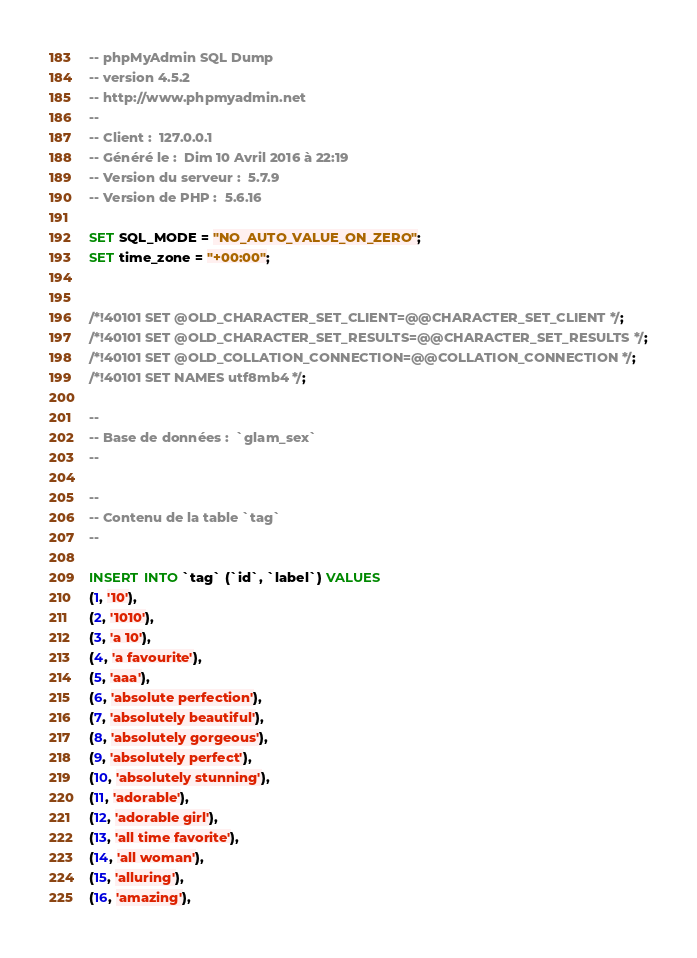Convert code to text. <code><loc_0><loc_0><loc_500><loc_500><_SQL_>-- phpMyAdmin SQL Dump
-- version 4.5.2
-- http://www.phpmyadmin.net
--
-- Client :  127.0.0.1
-- Généré le :  Dim 10 Avril 2016 à 22:19
-- Version du serveur :  5.7.9
-- Version de PHP :  5.6.16

SET SQL_MODE = "NO_AUTO_VALUE_ON_ZERO";
SET time_zone = "+00:00";


/*!40101 SET @OLD_CHARACTER_SET_CLIENT=@@CHARACTER_SET_CLIENT */;
/*!40101 SET @OLD_CHARACTER_SET_RESULTS=@@CHARACTER_SET_RESULTS */;
/*!40101 SET @OLD_COLLATION_CONNECTION=@@COLLATION_CONNECTION */;
/*!40101 SET NAMES utf8mb4 */;

--
-- Base de données :  `glam_sex`
--

--
-- Contenu de la table `tag`
--

INSERT INTO `tag` (`id`, `label`) VALUES
(1, '10'),
(2, '1010'),
(3, 'a 10'),
(4, 'a favourite'),
(5, 'aaa'),
(6, 'absolute perfection'),
(7, 'absolutely beautiful'),
(8, 'absolutely gorgeous'),
(9, 'absolutely perfect'),
(10, 'absolutely stunning'),
(11, 'adorable'),
(12, 'adorable girl'),
(13, 'all time favorite'),
(14, 'all woman'),
(15, 'alluring'),
(16, 'amazing'),</code> 